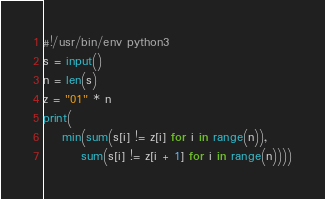<code> <loc_0><loc_0><loc_500><loc_500><_Python_>#!/usr/bin/env python3
s = input()
n = len(s)
z = "01" * n
print(
    min(sum(s[i] != z[i] for i in range(n)),
        sum(s[i] != z[i + 1] for i in range(n))))
</code> 